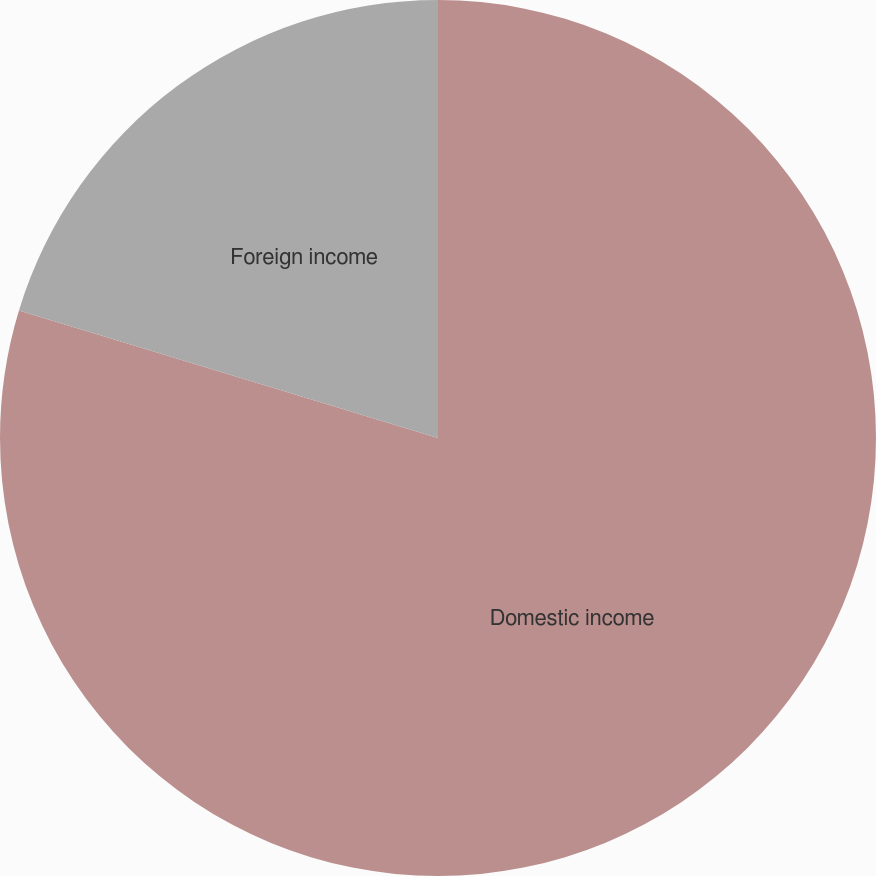Convert chart to OTSL. <chart><loc_0><loc_0><loc_500><loc_500><pie_chart><fcel>Domestic income<fcel>Foreign income<nl><fcel>79.7%<fcel>20.3%<nl></chart> 